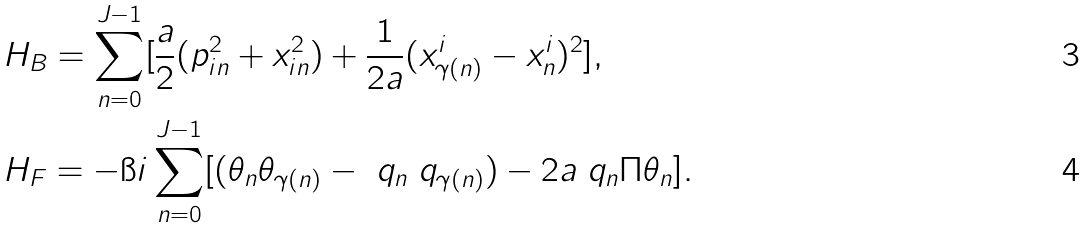Convert formula to latex. <formula><loc_0><loc_0><loc_500><loc_500>& H _ { B } = \sum _ { n = 0 } ^ { J - 1 } [ \frac { a } { 2 } ( p _ { i n } ^ { 2 } + x _ { i n } ^ { 2 } ) + \frac { 1 } { 2 a } ( x ^ { i } _ { \gamma ( n ) } - x ^ { i } _ { n } ) ^ { 2 } ] , \\ & H _ { F } = - \i i \sum _ { n = 0 } ^ { J - 1 } [ ( \theta _ { n } \theta _ { \gamma ( n ) } - \ q _ { n } \ q _ { \gamma ( n ) } ) - 2 a \ q _ { n } \Pi \theta _ { n } ] .</formula> 